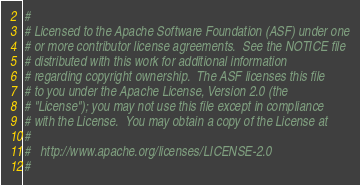Convert code to text. <code><loc_0><loc_0><loc_500><loc_500><_Python_>#
# Licensed to the Apache Software Foundation (ASF) under one
# or more contributor license agreements.  See the NOTICE file
# distributed with this work for additional information
# regarding copyright ownership.  The ASF licenses this file
# to you under the Apache License, Version 2.0 (the
# "License"); you may not use this file except in compliance
# with the License.  You may obtain a copy of the License at
#
#   http://www.apache.org/licenses/LICENSE-2.0
#</code> 